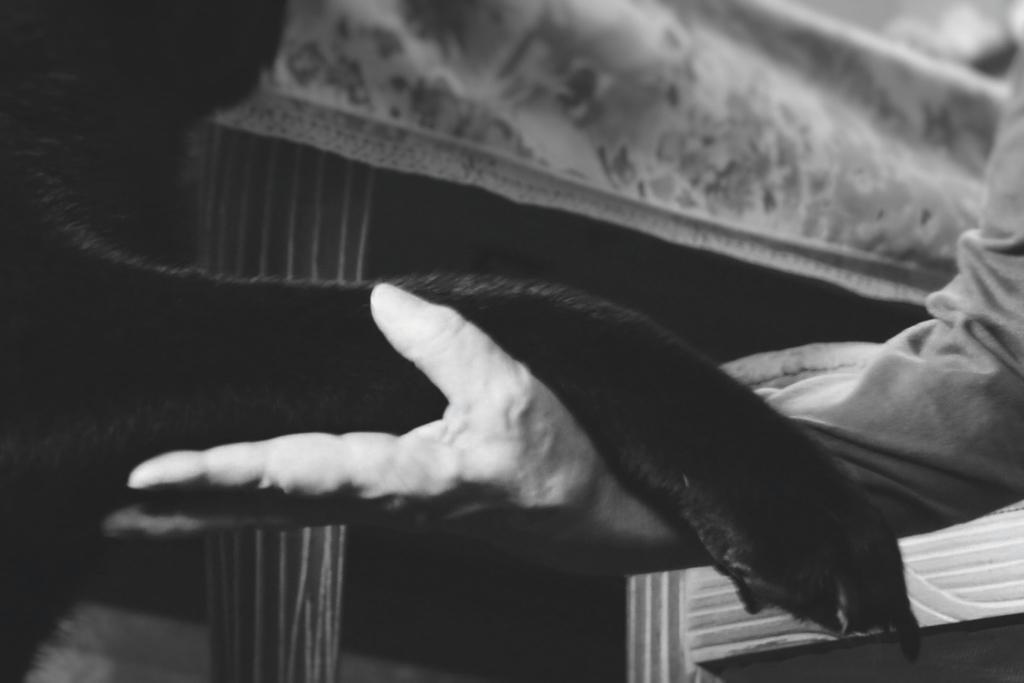How would you summarize this image in a sentence or two? This is a black and white image, where we can see a person holding an animal's leg, there is a table in the background. 